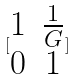Convert formula to latex. <formula><loc_0><loc_0><loc_500><loc_500>[ \begin{matrix} 1 & \frac { 1 } { G } \\ 0 & 1 \end{matrix} ]</formula> 